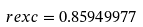<formula> <loc_0><loc_0><loc_500><loc_500>\ r e x c = 0 . 8 5 9 4 9 9 7 7</formula> 